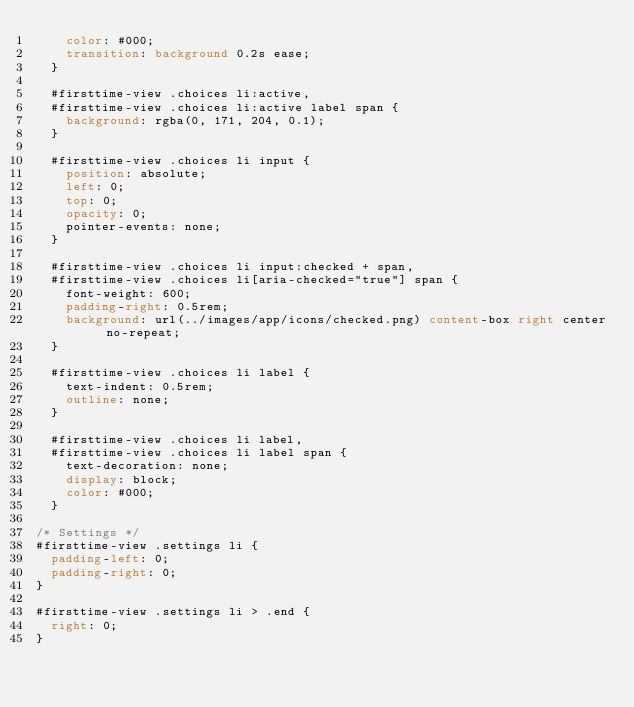<code> <loc_0><loc_0><loc_500><loc_500><_CSS_>    color: #000;
    transition: background 0.2s ease;
  }

  #firsttime-view .choices li:active,
  #firsttime-view .choices li:active label span {
    background: rgba(0, 171, 204, 0.1);
  }

  #firsttime-view .choices li input {
    position: absolute;
    left: 0;
    top: 0;
    opacity: 0;
    pointer-events: none;
  }

  #firsttime-view .choices li input:checked + span,
  #firsttime-view .choices li[aria-checked="true"] span {
    font-weight: 600;
    padding-right: 0.5rem;
    background: url(../images/app/icons/checked.png) content-box right center no-repeat;
  }

  #firsttime-view .choices li label {
    text-indent: 0.5rem;
    outline: none;
  }

  #firsttime-view .choices li label,
  #firsttime-view .choices li label span {
    text-decoration: none;
    display: block;
    color: #000;
  }

/* Settings */
#firsttime-view .settings li {
  padding-left: 0;
  padding-right: 0;
}

#firsttime-view .settings li > .end {
  right: 0;
}
</code> 